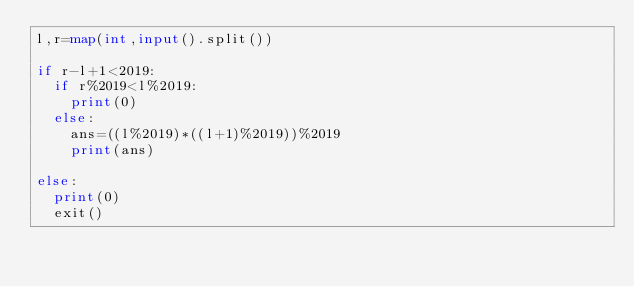<code> <loc_0><loc_0><loc_500><loc_500><_Python_>l,r=map(int,input().split())

if r-l+1<2019:
  if r%2019<l%2019:
    print(0)
  else:
    ans=((l%2019)*((l+1)%2019))%2019
    print(ans)
    
else:
  print(0)
  exit()</code> 